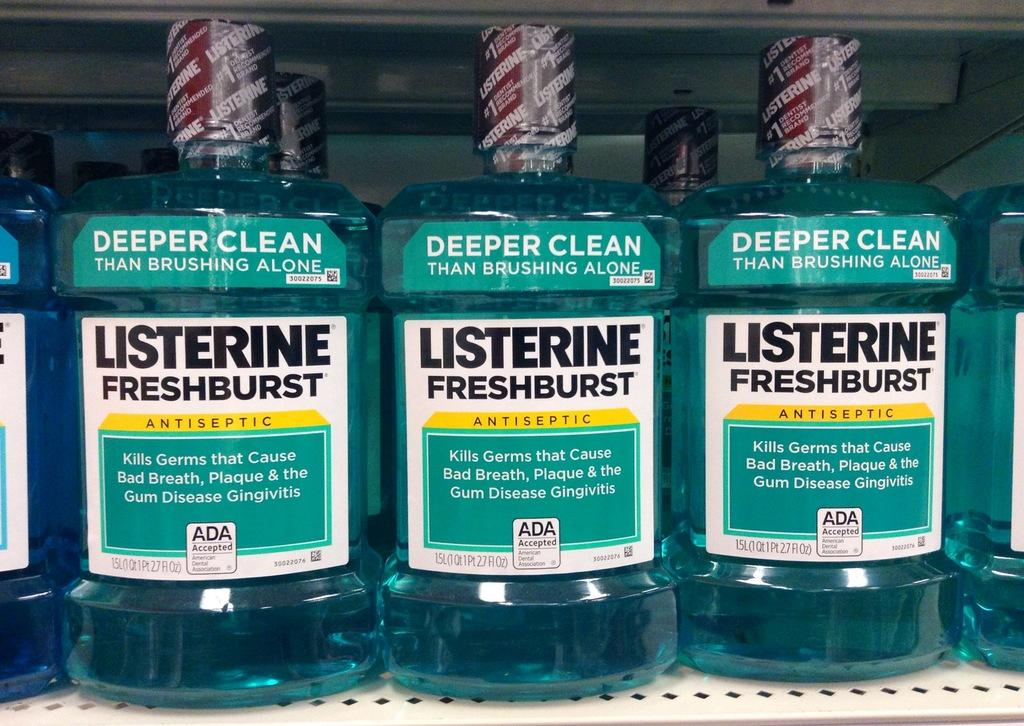<image>
Share a concise interpretation of the image provided. 3 bottles of Listerine Fresh Burst on display. 